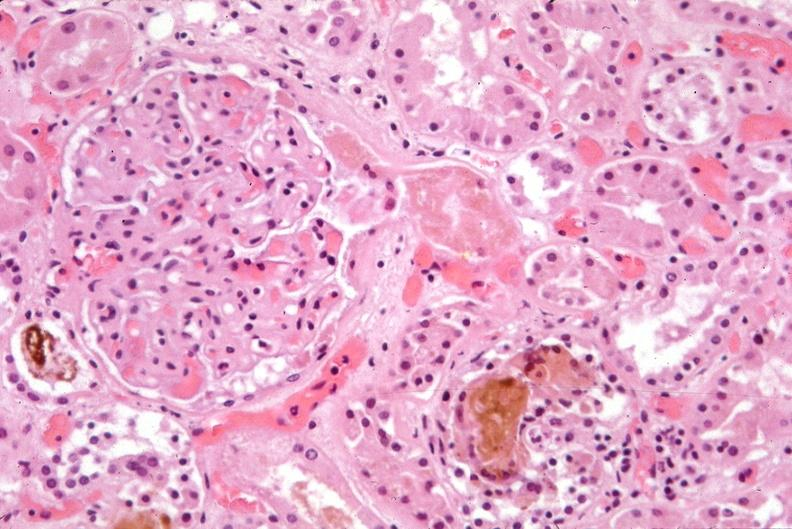does chancre show kidney, bile in tubules?
Answer the question using a single word or phrase. No 